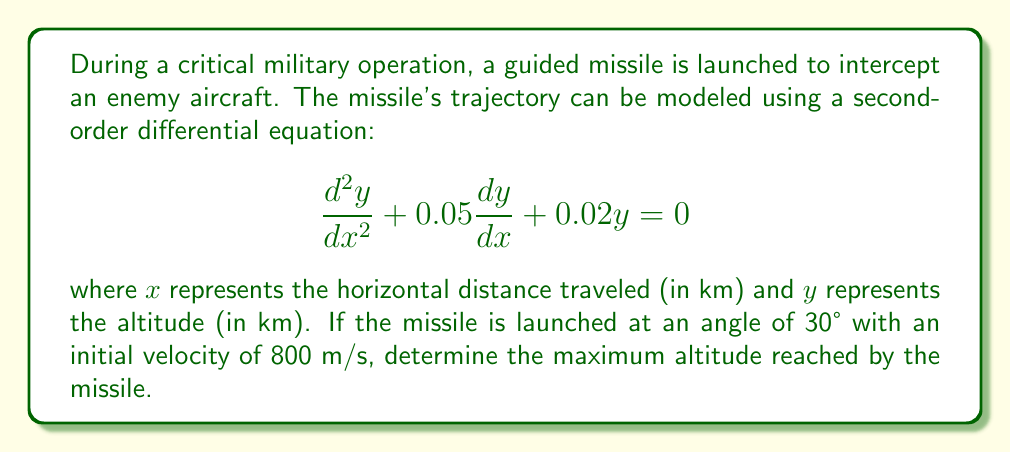Solve this math problem. To solve this problem, we'll follow these steps:

1) First, we need to recognize that this is a second-order linear homogeneous differential equation with constant coefficients. The general solution has the form:

   $$y = c_1e^{r_1x} + c_2e^{r_2x}$$

   where $r_1$ and $r_2$ are the roots of the characteristic equation.

2) The characteristic equation is:
   
   $$r^2 + 0.05r + 0.02 = 0$$

3) Solving this quadratic equation:
   
   $$r = \frac{-0.05 \pm \sqrt{0.05^2 - 4(1)(0.02)}}{2(1)}$$
   $$r = \frac{-0.05 \pm \sqrt{0.0025 - 0.08}}{2}$$
   $$r = \frac{-0.05 \pm \sqrt{-0.0775}}{2}$$
   $$r = -0.025 \pm 0.139i$$

4) Therefore, the general solution is:

   $$y = e^{-0.025x}(c_1\cos(0.139x) + c_2\sin(0.139x))$$

5) To find $c_1$ and $c_2$, we need initial conditions. We're given that the missile is launched at a 30° angle with an initial velocity of 800 m/s.

6) Initial conditions:
   At $x = 0$, $y = 0$
   At $x = 0$, $\frac{dy}{dx} = 800\sin(30°) = 400$ m/s = 0.4 km/s

7) Applying the first condition:
   
   $$0 = c_1$$

8) Differentiating $y$ with respect to $x$ and applying the second condition:

   $$\frac{dy}{dx} = e^{-0.025x}(-0.025c_1\cos(0.139x) - 0.025c_2\sin(0.139x) - 0.139c_1\sin(0.139x) + 0.139c_2\cos(0.139x))$$
   
   At $x = 0$:
   $$0.4 = 0.139c_2$$
   $$c_2 = 2.878$$

9) Therefore, the particular solution is:

   $$y = 2.878e^{-0.025x}\sin(0.139x)$$

10) To find the maximum altitude, we need to find where $\frac{dy}{dx} = 0$:

    $$\frac{dy}{dx} = 2.878e^{-0.025x}(-0.025\sin(0.139x) + 0.139\cos(0.139x)) = 0$$

    This occurs when $\tan(0.139x) = \frac{0.139}{0.025} = 5.56$

11) The smallest positive value of $x$ that satisfies this is approximately 1.41 km.

12) Plugging this back into our solution for $y$:

    $$y_{max} = 2.878e^{-0.025(1.41)}\sin(0.139(1.41)) \approx 0.399 \text{ km}$$
Answer: The maximum altitude reached by the missile is approximately 0.399 km or 399 meters. 